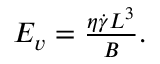<formula> <loc_0><loc_0><loc_500><loc_500>\begin{array} { r } { E _ { v } = \frac { \eta \dot { \gamma } L ^ { 3 } } { B } . } \end{array}</formula> 